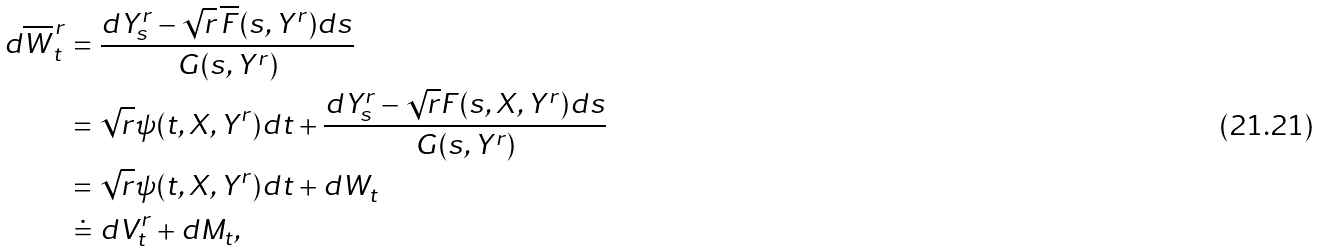<formula> <loc_0><loc_0><loc_500><loc_500>d \overline { W } ^ { \, r } _ { t } & = \frac { d Y ^ { r } _ { s } - \sqrt { r } \, \overline { F } ( s , Y ^ { r } ) d s } { G ( s , Y ^ { r } ) } \\ & = \sqrt { r } \psi ( t , X , Y ^ { r } ) d t + \frac { d Y ^ { r } _ { s } - \sqrt { r } F ( s , X , Y ^ { r } ) d s } { G ( s , Y ^ { r } ) } \\ & = \sqrt { r } \psi ( t , X , Y ^ { r } ) d t + d W _ { t } \\ & \doteq d V ^ { r } _ { t } + d M _ { t } ,</formula> 